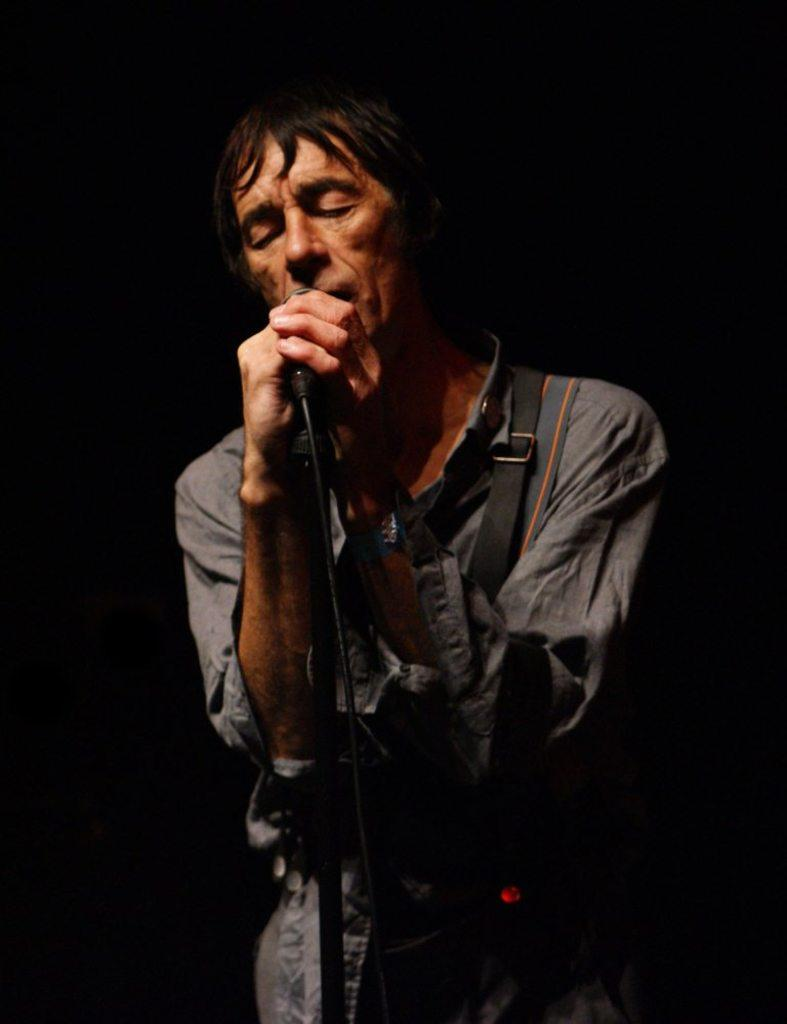What is the man in the image doing? The man is singing a song in the image. What is the man holding while singing? The man is holding a microphone. What color is the shirt the man is wearing? The man is wearing a grey color shirt. What type of produce can be seen growing on the hill in the image? There is no hill or produce present in the image; it features a man singing with a microphone. 